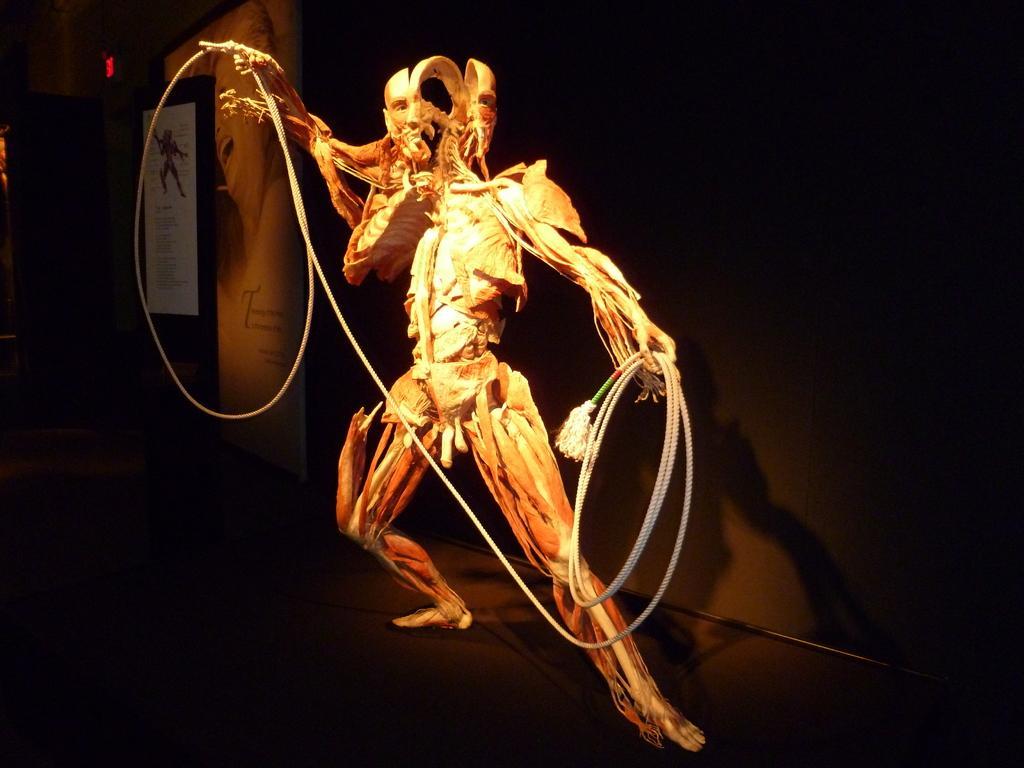Could you give a brief overview of what you see in this image? In the image there is a skeleton of a person with muscles. It is holding a rope. Behind the skeleton there's a wall. On the left side of the image there is a poster with image and text. Behind the poster on the wall there is an image and text. 